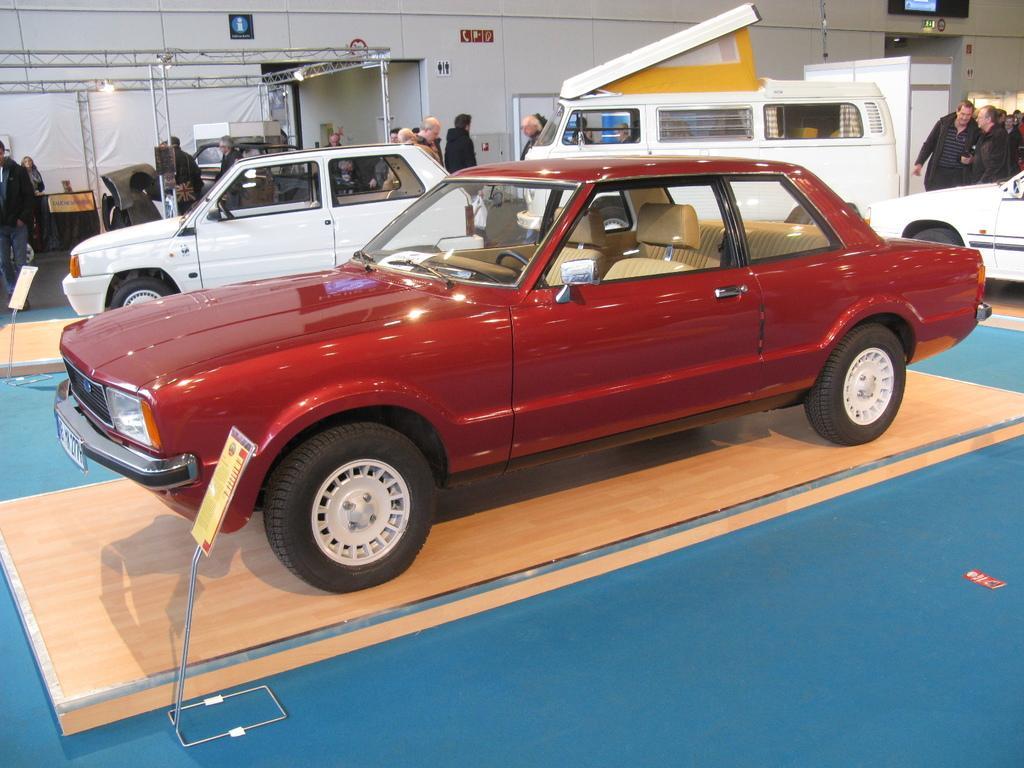Can you describe this image briefly? In this image I see a car in front and it is red in color. In the background I see 3 cars and few people. 